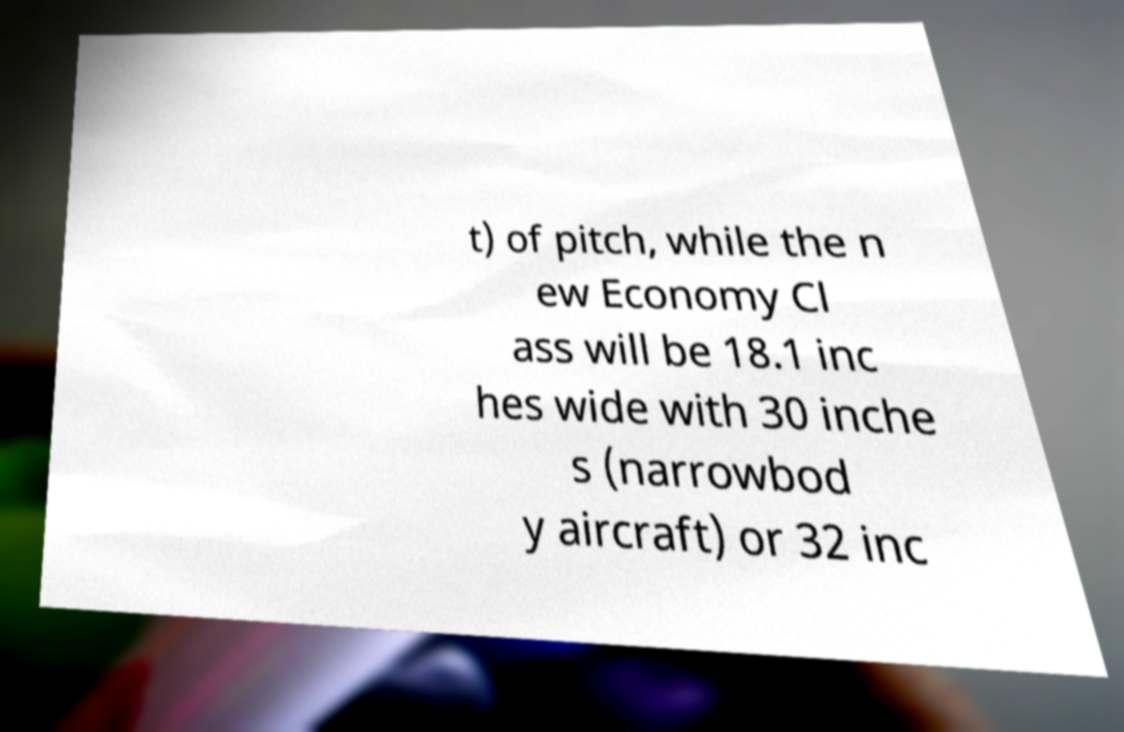What messages or text are displayed in this image? I need them in a readable, typed format. t) of pitch, while the n ew Economy Cl ass will be 18.1 inc hes wide with 30 inche s (narrowbod y aircraft) or 32 inc 